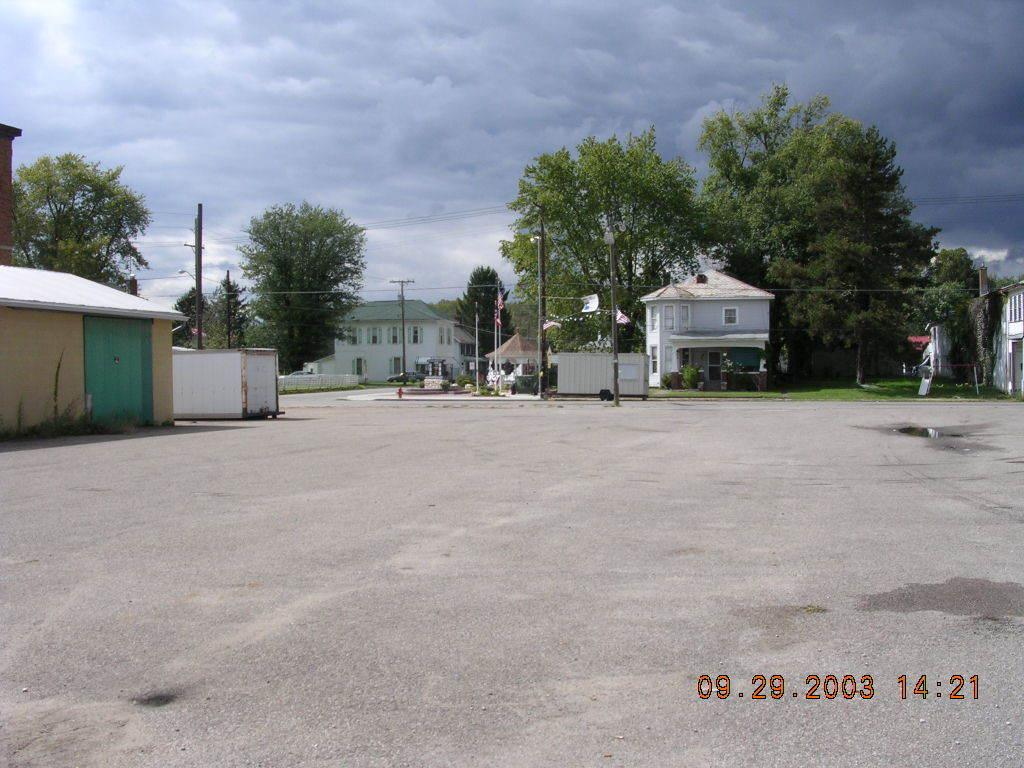What can be found in the bottom right of the image? There are numbers in the bottom right of the image. What is a prominent feature in the image? There is a road in the image. What can be seen in the background of the image? There are poles, houses, and trees in the background of the image. How would you describe the sky in the image? The sky is cloudy in the image. What type of bean is growing on the side of the road in the image? There are no beans visible in the image; it features a road, numbers, poles, houses, trees, and a cloudy sky. How does the hydrant help to control the heat in the image? There is no hydrant present in the image, so it cannot be used to control heat. 